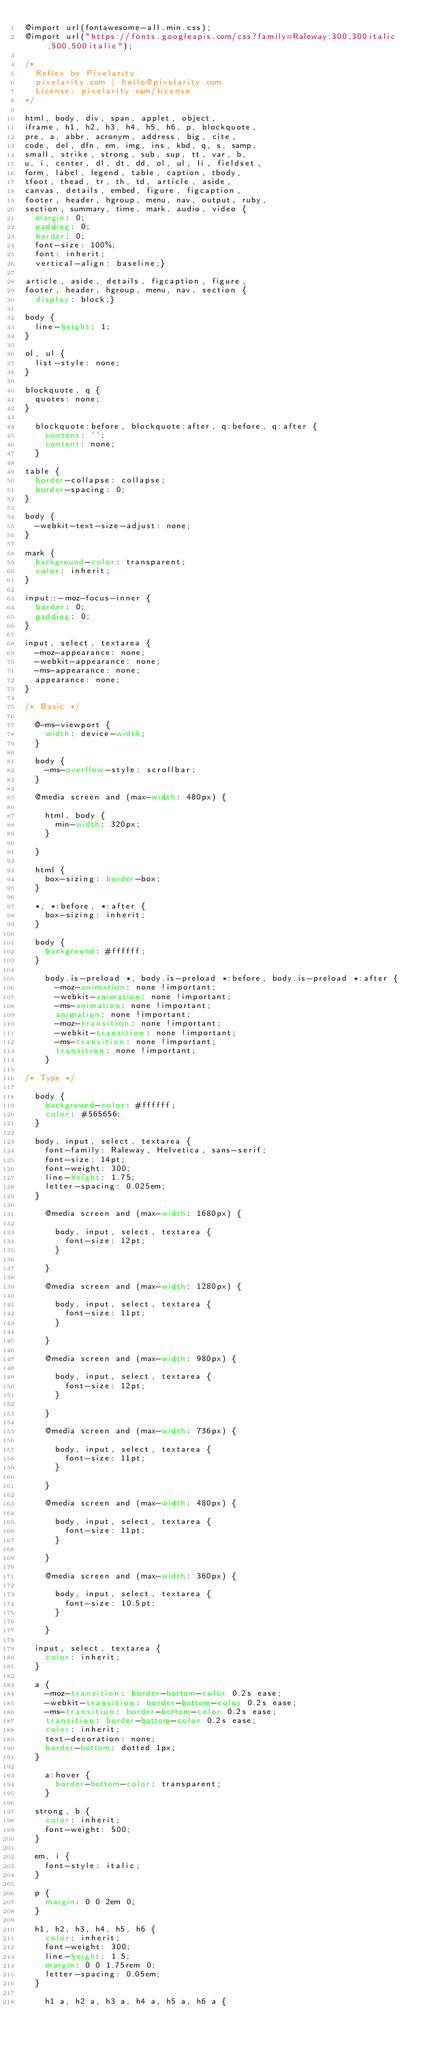Convert code to text. <code><loc_0><loc_0><loc_500><loc_500><_CSS_>@import url(fontawesome-all.min.css);
@import url("https://fonts.googleapis.com/css?family=Raleway:300,300italic,500,500italic");

/*
	Reflex by Pixelarity
	pixelarity.com | hello@pixelarity.com
	License: pixelarity.com/license
*/

html, body, div, span, applet, object,
iframe, h1, h2, h3, h4, h5, h6, p, blockquote,
pre, a, abbr, acronym, address, big, cite,
code, del, dfn, em, img, ins, kbd, q, s, samp,
small, strike, strong, sub, sup, tt, var, b,
u, i, center, dl, dt, dd, ol, ul, li, fieldset,
form, label, legend, table, caption, tbody,
tfoot, thead, tr, th, td, article, aside,
canvas, details, embed, figure, figcaption,
footer, header, hgroup, menu, nav, output, ruby,
section, summary, time, mark, audio, video {
	margin: 0;
	padding: 0;
	border: 0;
	font-size: 100%;
	font: inherit;
	vertical-align: baseline;}

article, aside, details, figcaption, figure,
footer, header, hgroup, menu, nav, section {
	display: block;}

body {
	line-height: 1;
}

ol, ul {
	list-style: none;
}

blockquote, q {
	quotes: none;
}

	blockquote:before, blockquote:after, q:before, q:after {
		content: '';
		content: none;
	}

table {
	border-collapse: collapse;
	border-spacing: 0;
}

body {
	-webkit-text-size-adjust: none;
}

mark {
	background-color: transparent;
	color: inherit;
}

input::-moz-focus-inner {
	border: 0;
	padding: 0;
}

input, select, textarea {
	-moz-appearance: none;
	-webkit-appearance: none;
	-ms-appearance: none;
	appearance: none;
}

/* Basic */

	@-ms-viewport {
		width: device-width;
	}

	body {
		-ms-overflow-style: scrollbar;
	}

	@media screen and (max-width: 480px) {

		html, body {
			min-width: 320px;
		}

	}

	html {
		box-sizing: border-box;
	}

	*, *:before, *:after {
		box-sizing: inherit;
	}

	body {
		background: #ffffff;
	}

		body.is-preload *, body.is-preload *:before, body.is-preload *:after {
			-moz-animation: none !important;
			-webkit-animation: none !important;
			-ms-animation: none !important;
			animation: none !important;
			-moz-transition: none !important;
			-webkit-transition: none !important;
			-ms-transition: none !important;
			transition: none !important;
		}

/* Type */

	body {
		background-color: #ffffff;
		color: #565656;
	}

	body, input, select, textarea {
		font-family: Raleway, Helvetica, sans-serif;
		font-size: 14pt;
		font-weight: 300;
		line-height: 1.75;
		letter-spacing: 0.025em;
	}

		@media screen and (max-width: 1680px) {

			body, input, select, textarea {
				font-size: 12pt;
			}

		}

		@media screen and (max-width: 1280px) {

			body, input, select, textarea {
				font-size: 11pt;
			}

		}

		@media screen and (max-width: 980px) {

			body, input, select, textarea {
				font-size: 12pt;
			}

		}

		@media screen and (max-width: 736px) {

			body, input, select, textarea {
				font-size: 11pt;
			}

		}

		@media screen and (max-width: 480px) {

			body, input, select, textarea {
				font-size: 11pt;
			}

		}

		@media screen and (max-width: 360px) {

			body, input, select, textarea {
				font-size: 10.5pt;
			}

		}

	input, select, textarea {
		color: inherit;
	}

	a {
		-moz-transition: border-bottom-color 0.2s ease;
		-webkit-transition: border-bottom-color 0.2s ease;
		-ms-transition: border-bottom-color 0.2s ease;
		transition: border-bottom-color 0.2s ease;
		color: inherit;
		text-decoration: none;
		border-bottom: dotted 1px;
	}

		a:hover {
			border-bottom-color: transparent;
		}

	strong, b {
		color: inherit;
		font-weight: 500;
	}

	em, i {
		font-style: italic;
	}

	p {
		margin: 0 0 2em 0;
	}

	h1, h2, h3, h4, h5, h6 {
		color: inherit;
		font-weight: 300;
		line-height: 1.5;
		margin: 0 0 1.75rem 0;
		letter-spacing: 0.05em;
	}

		h1 a, h2 a, h3 a, h4 a, h5 a, h6 a {</code> 